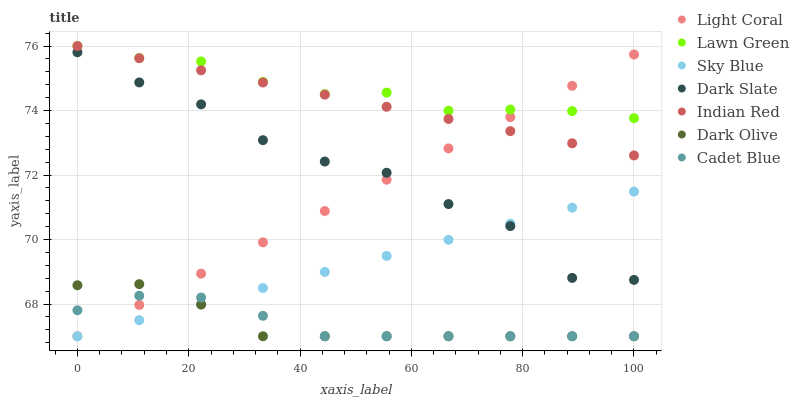Does Dark Olive have the minimum area under the curve?
Answer yes or no. Yes. Does Lawn Green have the maximum area under the curve?
Answer yes or no. Yes. Does Cadet Blue have the minimum area under the curve?
Answer yes or no. No. Does Cadet Blue have the maximum area under the curve?
Answer yes or no. No. Is Light Coral the smoothest?
Answer yes or no. Yes. Is Dark Slate the roughest?
Answer yes or no. Yes. Is Cadet Blue the smoothest?
Answer yes or no. No. Is Cadet Blue the roughest?
Answer yes or no. No. Does Cadet Blue have the lowest value?
Answer yes or no. Yes. Does Dark Slate have the lowest value?
Answer yes or no. No. Does Indian Red have the highest value?
Answer yes or no. Yes. Does Dark Olive have the highest value?
Answer yes or no. No. Is Dark Olive less than Indian Red?
Answer yes or no. Yes. Is Lawn Green greater than Cadet Blue?
Answer yes or no. Yes. Does Indian Red intersect Light Coral?
Answer yes or no. Yes. Is Indian Red less than Light Coral?
Answer yes or no. No. Is Indian Red greater than Light Coral?
Answer yes or no. No. Does Dark Olive intersect Indian Red?
Answer yes or no. No. 